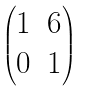<formula> <loc_0><loc_0><loc_500><loc_500>\begin{pmatrix} 1 & 6 \\ 0 & 1 \end{pmatrix}</formula> 